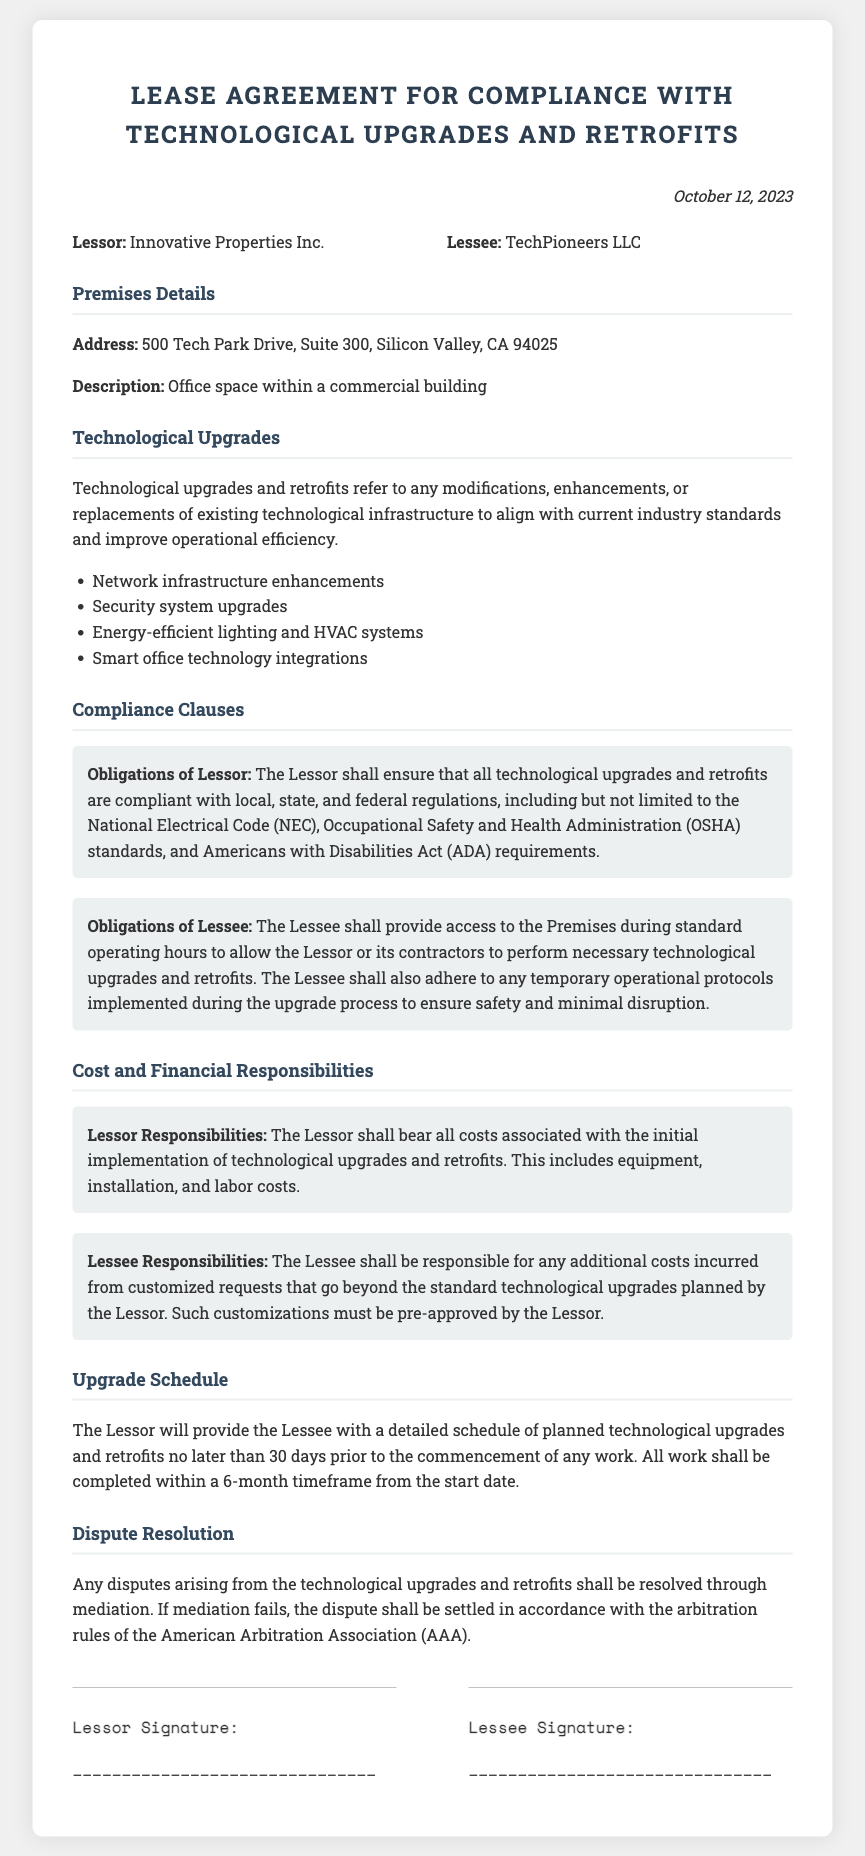What is the date of the agreement? The date of the agreement is specified at the top of the document.
Answer: October 12, 2023 Who is the Lessor? The Lessor is identified in the document as the party providing the premises.
Answer: Innovative Properties Inc What is included in the list of technological upgrades? The document outlines various upgrades in the section for Technological Upgrades.
Answer: Network infrastructure enhancements What are the Lessee's responsibilities regarding costs? The responsibilities of the Lessee regarding costs are detailed in the financial responsibilities section.
Answer: Additional costs incurred from customized requests What is the timeframe for completing the upgrades? The timeframe for completing the upgrades is stated under the Upgrade Schedule section.
Answer: 6 months What is the method of dispute resolution? The document specifies the process for resolving disputes in the Dispute Resolution section.
Answer: Mediation What must the Lessor ensure regarding upgrades? The responsibilities of the Lessor are clearly stated in the Compliance Clauses section.
Answer: Compliance with local, state, and federal regulations What happens if mediation fails? The document explains the next steps in dispute resolution if mediation is unsuccessful.
Answer: Settled in accordance with the arbitration rules of AAA 